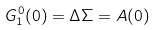<formula> <loc_0><loc_0><loc_500><loc_500>G ^ { 0 } _ { 1 } ( 0 ) = \Delta \Sigma = A ( 0 )</formula> 